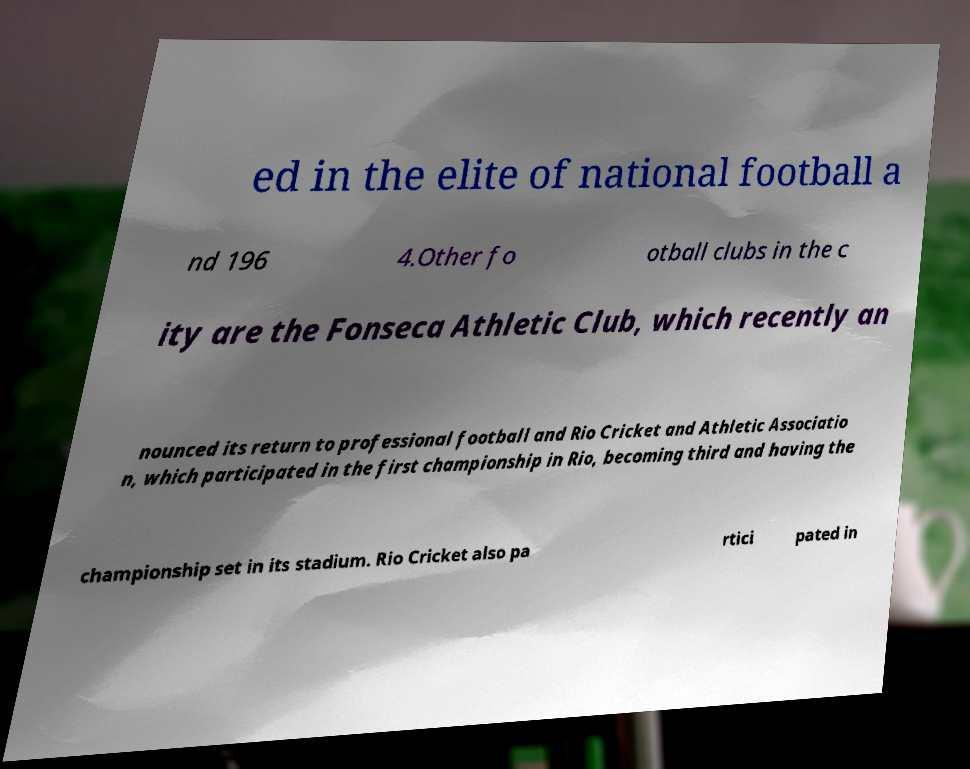Can you accurately transcribe the text from the provided image for me? ed in the elite of national football a nd 196 4.Other fo otball clubs in the c ity are the Fonseca Athletic Club, which recently an nounced its return to professional football and Rio Cricket and Athletic Associatio n, which participated in the first championship in Rio, becoming third and having the championship set in its stadium. Rio Cricket also pa rtici pated in 